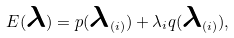<formula> <loc_0><loc_0><loc_500><loc_500>E ( { \boldsymbol \lambda } ) = p ( { \boldsymbol \lambda } _ { ( i ) } ) + \lambda _ { i } q ( { \boldsymbol \lambda } _ { ( i ) } ) ,</formula> 